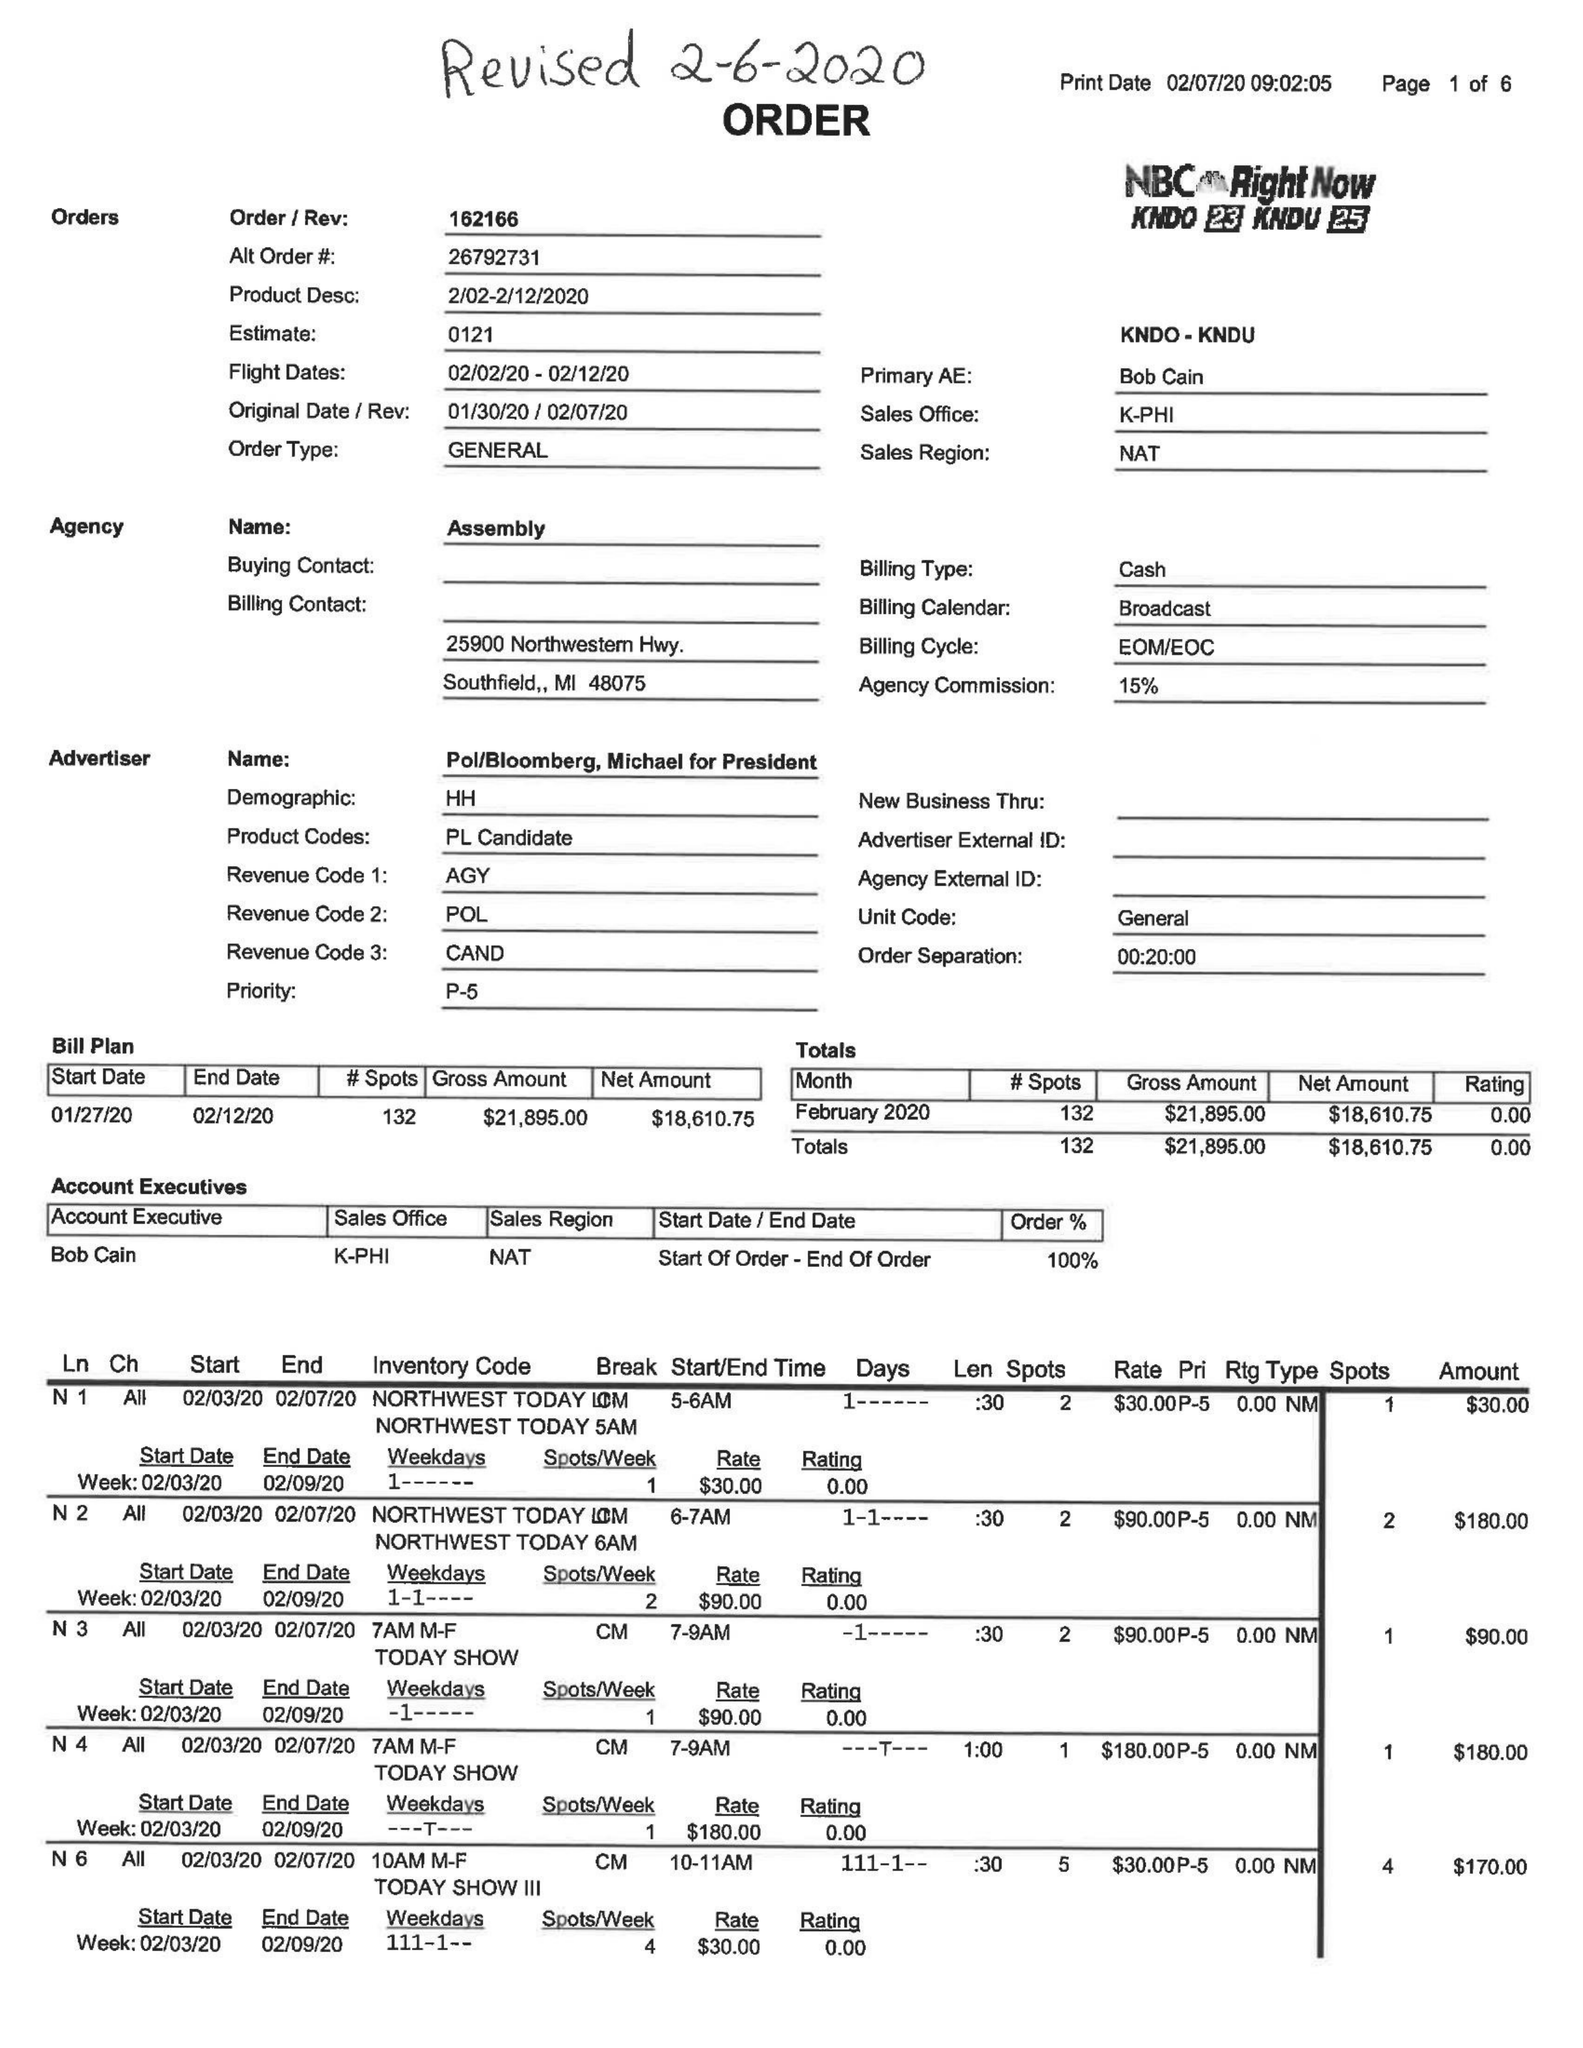What is the value for the flight_to?
Answer the question using a single word or phrase. 02/12/20 